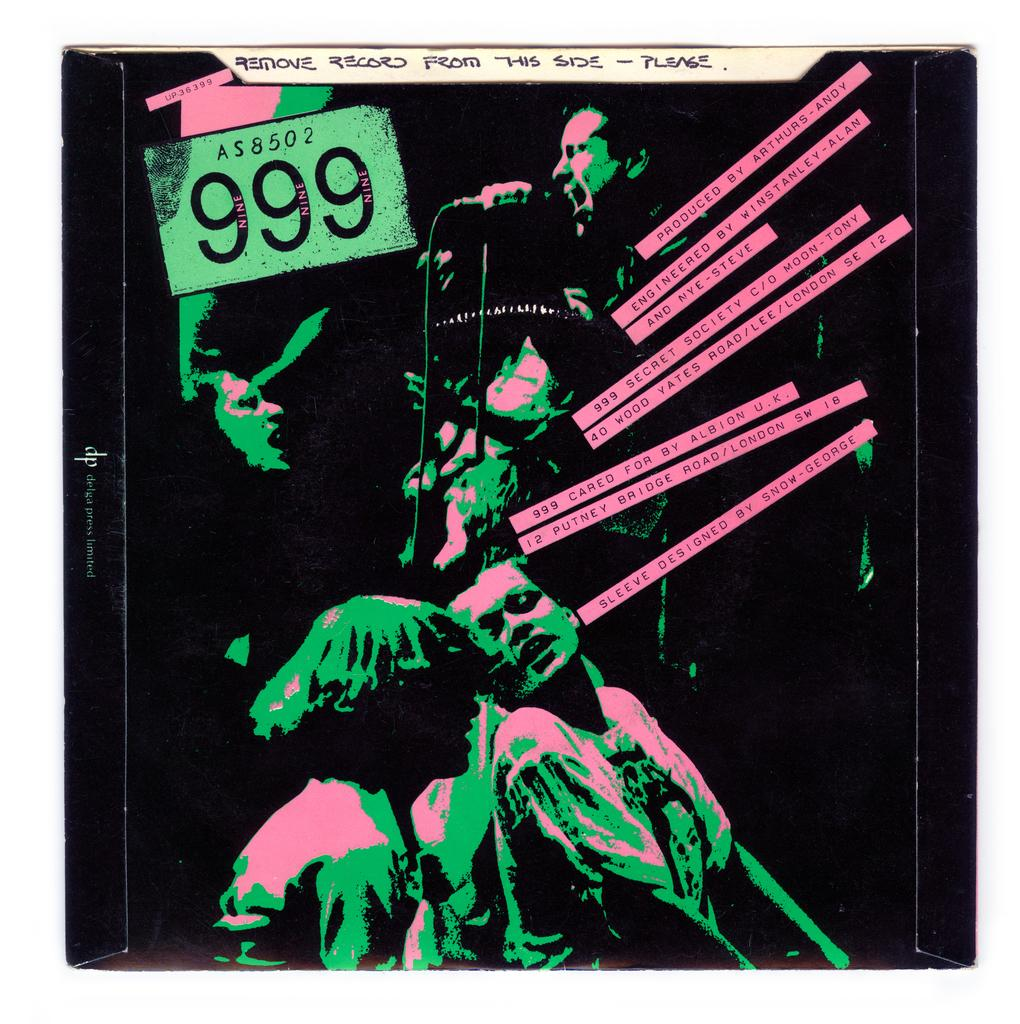<image>
Present a compact description of the photo's key features. An album cover of a 999 record with a note saying "remove record from this side - please" 